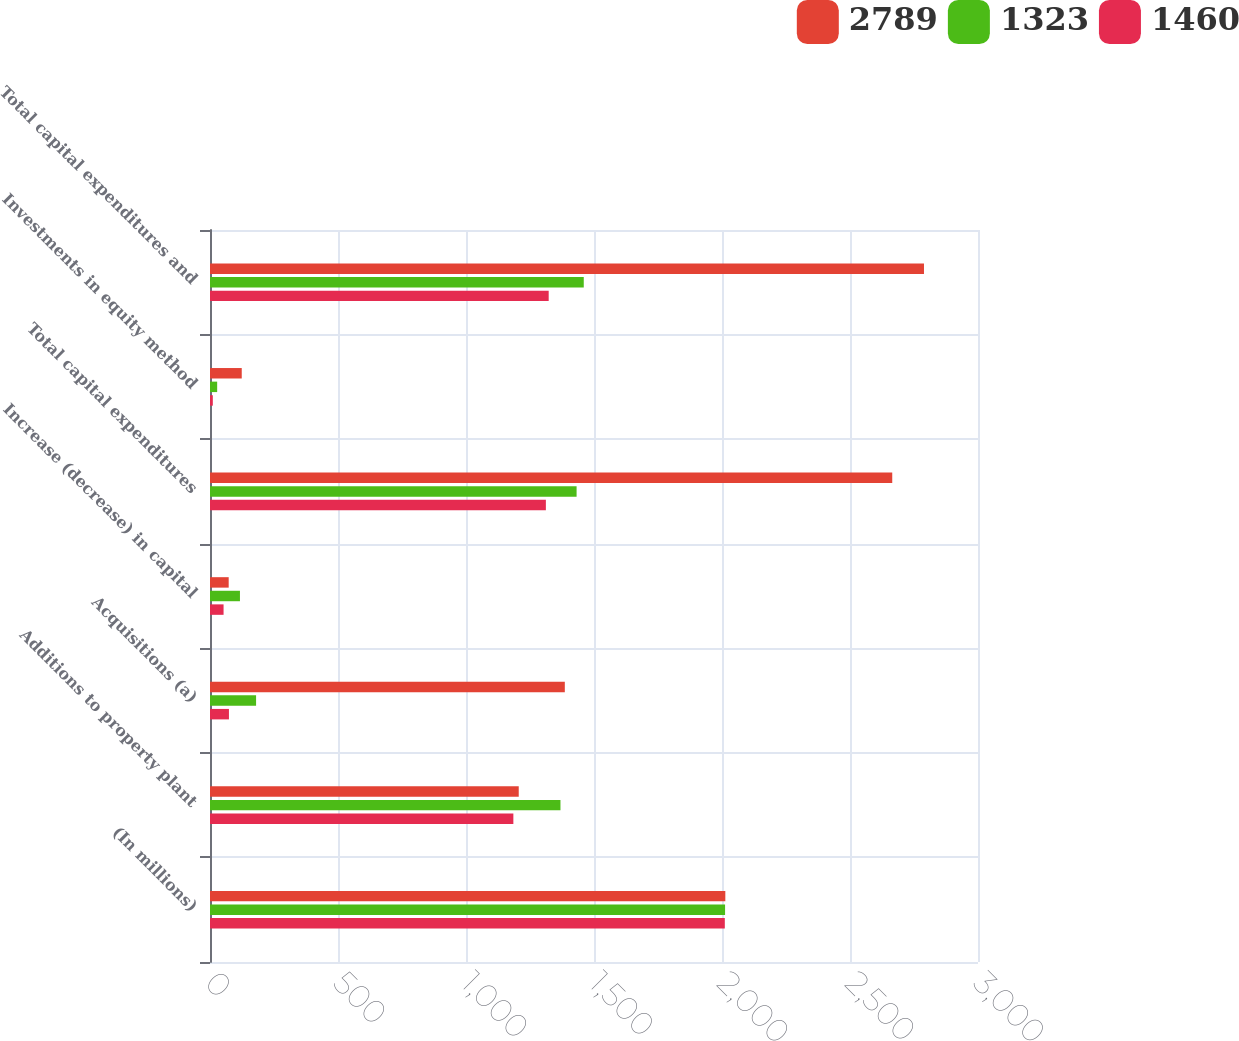Convert chart. <chart><loc_0><loc_0><loc_500><loc_500><stacked_bar_chart><ecel><fcel>(In millions)<fcel>Additions to property plant<fcel>Acquisitions (a)<fcel>Increase (decrease) in capital<fcel>Total capital expenditures<fcel>Investments in equity method<fcel>Total capital expenditures and<nl><fcel>2789<fcel>2013<fcel>1206<fcel>1386<fcel>73<fcel>2665<fcel>124<fcel>2789<nl><fcel>1323<fcel>2012<fcel>1369<fcel>180<fcel>117<fcel>1432<fcel>28<fcel>1460<nl><fcel>1460<fcel>2011<fcel>1185<fcel>74<fcel>53<fcel>1312<fcel>11<fcel>1323<nl></chart> 